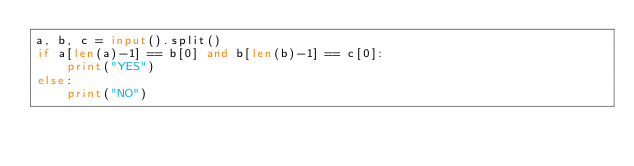<code> <loc_0><loc_0><loc_500><loc_500><_Python_>a, b, c = input().split()
if a[len(a)-1] == b[0] and b[len(b)-1] == c[0]:
    print("YES")
else:
    print("NO")
</code> 